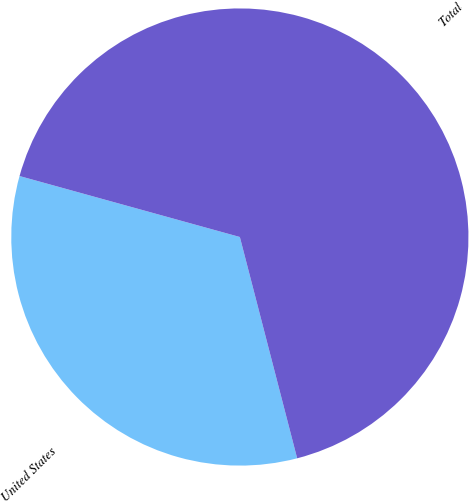Convert chart to OTSL. <chart><loc_0><loc_0><loc_500><loc_500><pie_chart><fcel>United States<fcel>Total<nl><fcel>33.33%<fcel>66.67%<nl></chart> 